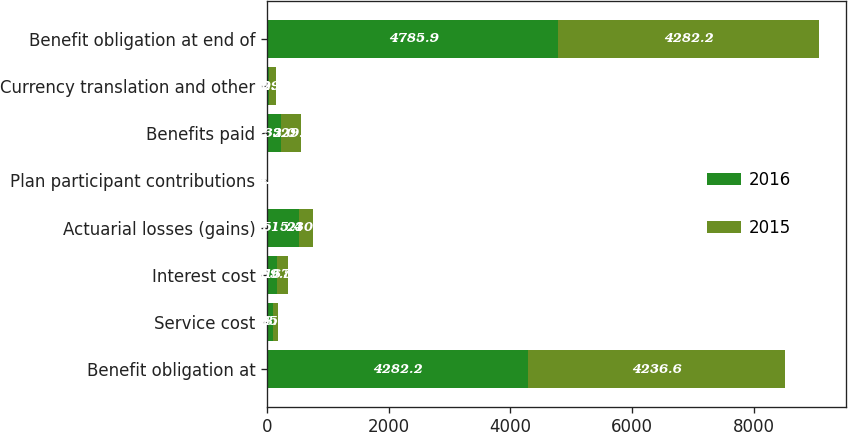Convert chart. <chart><loc_0><loc_0><loc_500><loc_500><stacked_bar_chart><ecel><fcel>Benefit obligation at<fcel>Service cost<fcel>Interest cost<fcel>Actuarial losses (gains)<fcel>Plan participant contributions<fcel>Benefits paid<fcel>Currency translation and other<fcel>Benefit obligation at end of<nl><fcel>2016<fcel>4282.2<fcel>88<fcel>169.5<fcel>515.4<fcel>4.3<fcel>232<fcel>32<fcel>4785.9<nl><fcel>2015<fcel>4236.6<fcel>85.7<fcel>167.2<fcel>230.2<fcel>4.9<fcel>329.1<fcel>109.8<fcel>4282.2<nl></chart> 